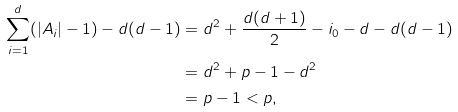Convert formula to latex. <formula><loc_0><loc_0><loc_500><loc_500>\sum _ { i = 1 } ^ { d } ( | A _ { i } | - 1 ) - d ( d - 1 ) & = d ^ { 2 } + \frac { d ( d + 1 ) } { 2 } - i _ { 0 } - d - d ( d - 1 ) \\ & = d ^ { 2 } + p - 1 - d ^ { 2 } \\ & = p - 1 < p ,</formula> 